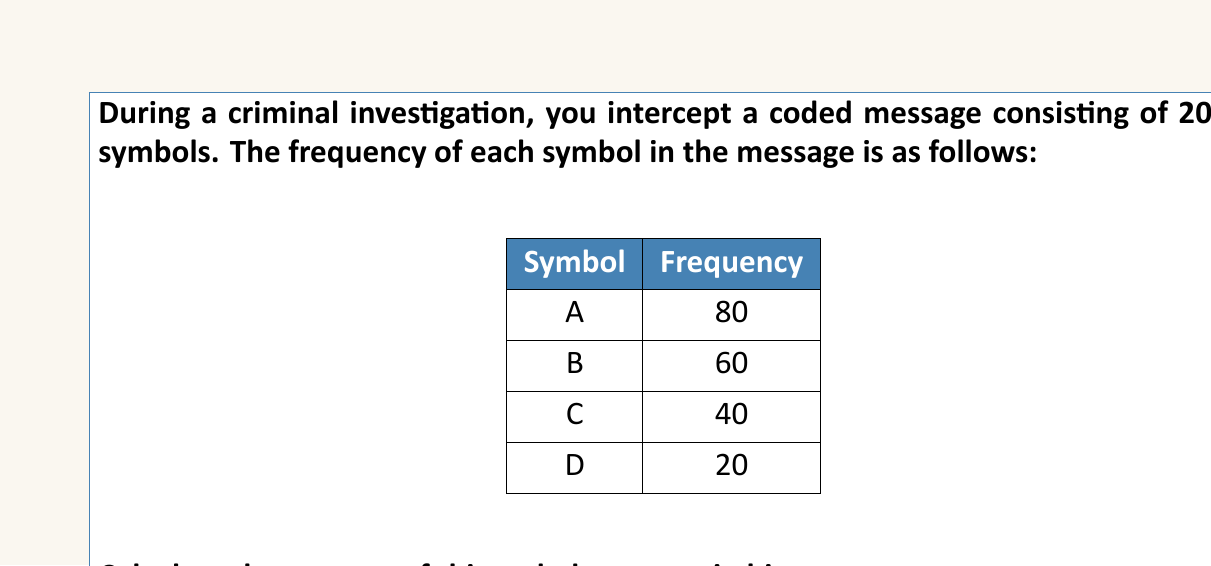Solve this math problem. To calculate the entropy of the coded message, we'll follow these steps:

1) First, we need to calculate the probability of each symbol:

   $P(A) = \frac{80}{200} = 0.4$
   $P(B) = \frac{60}{200} = 0.3$
   $P(C) = \frac{40}{200} = 0.2$
   $P(D) = \frac{20}{200} = 0.1$

2) The entropy formula in information theory is:

   $$H = -\sum_{i=1}^{n} P(x_i) \log_2 P(x_i)$$

   where $P(x_i)$ is the probability of symbol $x_i$.

3) Let's calculate each term:

   $-P(A) \log_2 P(A) = -0.4 \log_2 0.4 = 0.528321$
   $-P(B) \log_2 P(B) = -0.3 \log_2 0.3 = 0.521061$
   $-P(C) \log_2 P(C) = -0.2 \log_2 0.2 = 0.464386$
   $-P(D) \log_2 P(D) = -0.1 \log_2 0.1 = 0.332193$

4) Sum all these terms:

   $H = 0.528321 + 0.521061 + 0.464386 + 0.332193 = 1.845961$

Therefore, the entropy of the coded message is approximately 1.846 bits.
Answer: 1.846 bits 